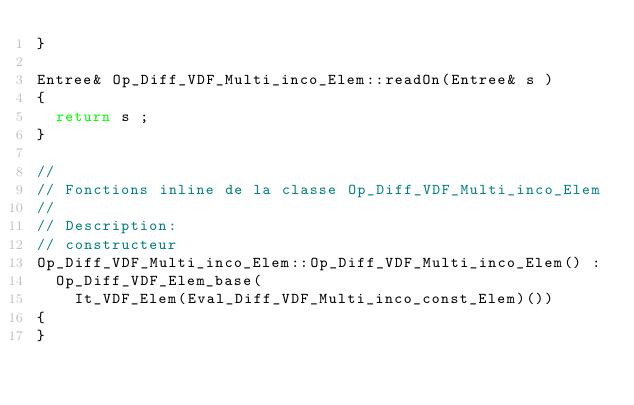Convert code to text. <code><loc_0><loc_0><loc_500><loc_500><_C++_>}

Entree& Op_Diff_VDF_Multi_inco_Elem::readOn(Entree& s )
{
  return s ;
}

//
// Fonctions inline de la classe Op_Diff_VDF_Multi_inco_Elem
//
// Description:
// constructeur
Op_Diff_VDF_Multi_inco_Elem::Op_Diff_VDF_Multi_inco_Elem() :
  Op_Diff_VDF_Elem_base(
    It_VDF_Elem(Eval_Diff_VDF_Multi_inco_const_Elem)())
{
}
</code> 